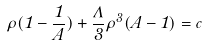<formula> <loc_0><loc_0><loc_500><loc_500>\rho ( 1 - \frac { 1 } { A } ) + \frac { \Lambda } { 3 } \rho ^ { 3 } ( A - 1 ) = c \,</formula> 